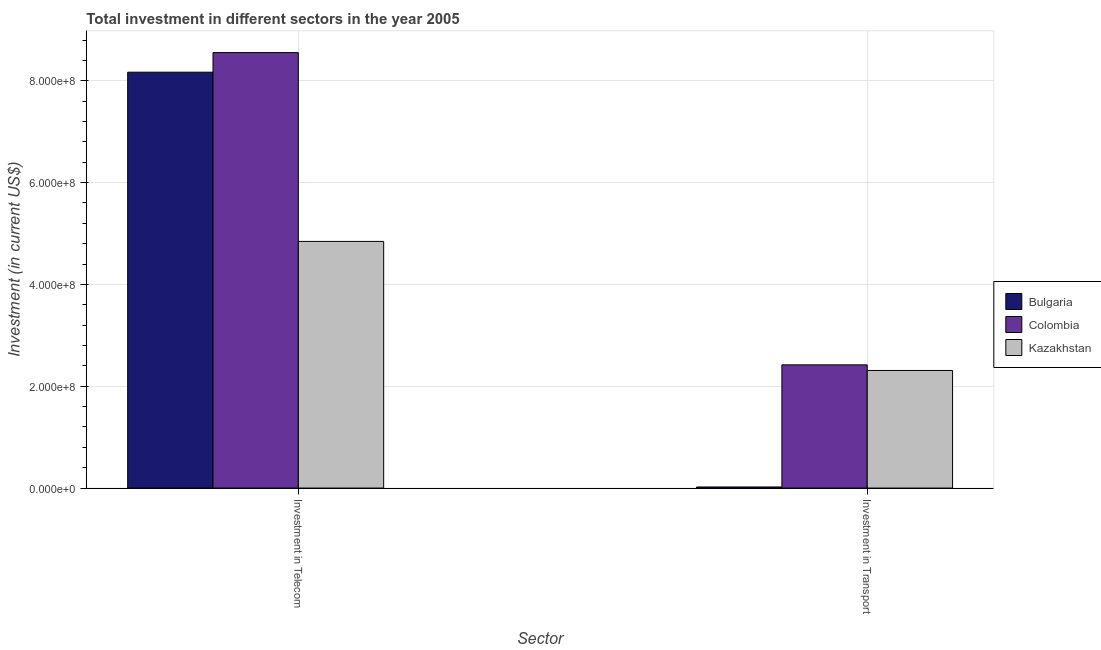How many groups of bars are there?
Give a very brief answer. 2. How many bars are there on the 2nd tick from the left?
Your response must be concise. 3. How many bars are there on the 2nd tick from the right?
Provide a short and direct response. 3. What is the label of the 1st group of bars from the left?
Offer a very short reply. Investment in Telecom. What is the investment in transport in Bulgaria?
Give a very brief answer. 2.12e+06. Across all countries, what is the maximum investment in telecom?
Your answer should be very brief. 8.55e+08. Across all countries, what is the minimum investment in telecom?
Give a very brief answer. 4.84e+08. In which country was the investment in telecom minimum?
Make the answer very short. Kazakhstan. What is the total investment in telecom in the graph?
Give a very brief answer. 2.16e+09. What is the difference between the investment in telecom in Bulgaria and that in Colombia?
Your answer should be very brief. -3.85e+07. What is the difference between the investment in transport in Kazakhstan and the investment in telecom in Bulgaria?
Give a very brief answer. -5.86e+08. What is the average investment in transport per country?
Your response must be concise. 1.58e+08. What is the difference between the investment in transport and investment in telecom in Bulgaria?
Give a very brief answer. -8.15e+08. What is the ratio of the investment in transport in Bulgaria to that in Colombia?
Your response must be concise. 0.01. Is the investment in telecom in Kazakhstan less than that in Bulgaria?
Offer a very short reply. Yes. What does the 1st bar from the right in Investment in Telecom represents?
Keep it short and to the point. Kazakhstan. How many bars are there?
Your answer should be compact. 6. How many countries are there in the graph?
Make the answer very short. 3. Does the graph contain any zero values?
Provide a succinct answer. No. Does the graph contain grids?
Give a very brief answer. Yes. How many legend labels are there?
Offer a terse response. 3. How are the legend labels stacked?
Keep it short and to the point. Vertical. What is the title of the graph?
Your answer should be compact. Total investment in different sectors in the year 2005. Does "Switzerland" appear as one of the legend labels in the graph?
Provide a short and direct response. No. What is the label or title of the X-axis?
Your answer should be compact. Sector. What is the label or title of the Y-axis?
Make the answer very short. Investment (in current US$). What is the Investment (in current US$) in Bulgaria in Investment in Telecom?
Your response must be concise. 8.17e+08. What is the Investment (in current US$) in Colombia in Investment in Telecom?
Your answer should be compact. 8.55e+08. What is the Investment (in current US$) in Kazakhstan in Investment in Telecom?
Give a very brief answer. 4.84e+08. What is the Investment (in current US$) in Bulgaria in Investment in Transport?
Offer a terse response. 2.12e+06. What is the Investment (in current US$) in Colombia in Investment in Transport?
Your answer should be very brief. 2.42e+08. What is the Investment (in current US$) in Kazakhstan in Investment in Transport?
Offer a terse response. 2.31e+08. Across all Sector, what is the maximum Investment (in current US$) in Bulgaria?
Give a very brief answer. 8.17e+08. Across all Sector, what is the maximum Investment (in current US$) in Colombia?
Make the answer very short. 8.55e+08. Across all Sector, what is the maximum Investment (in current US$) in Kazakhstan?
Offer a terse response. 4.84e+08. Across all Sector, what is the minimum Investment (in current US$) of Bulgaria?
Give a very brief answer. 2.12e+06. Across all Sector, what is the minimum Investment (in current US$) of Colombia?
Ensure brevity in your answer.  2.42e+08. Across all Sector, what is the minimum Investment (in current US$) of Kazakhstan?
Ensure brevity in your answer.  2.31e+08. What is the total Investment (in current US$) in Bulgaria in the graph?
Give a very brief answer. 8.19e+08. What is the total Investment (in current US$) of Colombia in the graph?
Offer a terse response. 1.10e+09. What is the total Investment (in current US$) of Kazakhstan in the graph?
Your response must be concise. 7.16e+08. What is the difference between the Investment (in current US$) in Bulgaria in Investment in Telecom and that in Investment in Transport?
Give a very brief answer. 8.15e+08. What is the difference between the Investment (in current US$) of Colombia in Investment in Telecom and that in Investment in Transport?
Your answer should be very brief. 6.13e+08. What is the difference between the Investment (in current US$) of Kazakhstan in Investment in Telecom and that in Investment in Transport?
Your response must be concise. 2.54e+08. What is the difference between the Investment (in current US$) in Bulgaria in Investment in Telecom and the Investment (in current US$) in Colombia in Investment in Transport?
Offer a terse response. 5.75e+08. What is the difference between the Investment (in current US$) in Bulgaria in Investment in Telecom and the Investment (in current US$) in Kazakhstan in Investment in Transport?
Make the answer very short. 5.86e+08. What is the difference between the Investment (in current US$) in Colombia in Investment in Telecom and the Investment (in current US$) in Kazakhstan in Investment in Transport?
Your response must be concise. 6.24e+08. What is the average Investment (in current US$) of Bulgaria per Sector?
Provide a succinct answer. 4.10e+08. What is the average Investment (in current US$) in Colombia per Sector?
Offer a very short reply. 5.49e+08. What is the average Investment (in current US$) in Kazakhstan per Sector?
Your answer should be very brief. 3.58e+08. What is the difference between the Investment (in current US$) in Bulgaria and Investment (in current US$) in Colombia in Investment in Telecom?
Provide a short and direct response. -3.85e+07. What is the difference between the Investment (in current US$) in Bulgaria and Investment (in current US$) in Kazakhstan in Investment in Telecom?
Your answer should be compact. 3.32e+08. What is the difference between the Investment (in current US$) in Colombia and Investment (in current US$) in Kazakhstan in Investment in Telecom?
Keep it short and to the point. 3.71e+08. What is the difference between the Investment (in current US$) of Bulgaria and Investment (in current US$) of Colombia in Investment in Transport?
Ensure brevity in your answer.  -2.40e+08. What is the difference between the Investment (in current US$) in Bulgaria and Investment (in current US$) in Kazakhstan in Investment in Transport?
Give a very brief answer. -2.29e+08. What is the difference between the Investment (in current US$) of Colombia and Investment (in current US$) of Kazakhstan in Investment in Transport?
Your answer should be compact. 1.10e+07. What is the ratio of the Investment (in current US$) of Bulgaria in Investment in Telecom to that in Investment in Transport?
Offer a very short reply. 385.33. What is the ratio of the Investment (in current US$) of Colombia in Investment in Telecom to that in Investment in Transport?
Make the answer very short. 3.53. What is the ratio of the Investment (in current US$) of Kazakhstan in Investment in Telecom to that in Investment in Transport?
Ensure brevity in your answer.  2.1. What is the difference between the highest and the second highest Investment (in current US$) in Bulgaria?
Offer a terse response. 8.15e+08. What is the difference between the highest and the second highest Investment (in current US$) of Colombia?
Provide a succinct answer. 6.13e+08. What is the difference between the highest and the second highest Investment (in current US$) of Kazakhstan?
Provide a short and direct response. 2.54e+08. What is the difference between the highest and the lowest Investment (in current US$) in Bulgaria?
Provide a short and direct response. 8.15e+08. What is the difference between the highest and the lowest Investment (in current US$) in Colombia?
Provide a succinct answer. 6.13e+08. What is the difference between the highest and the lowest Investment (in current US$) in Kazakhstan?
Make the answer very short. 2.54e+08. 